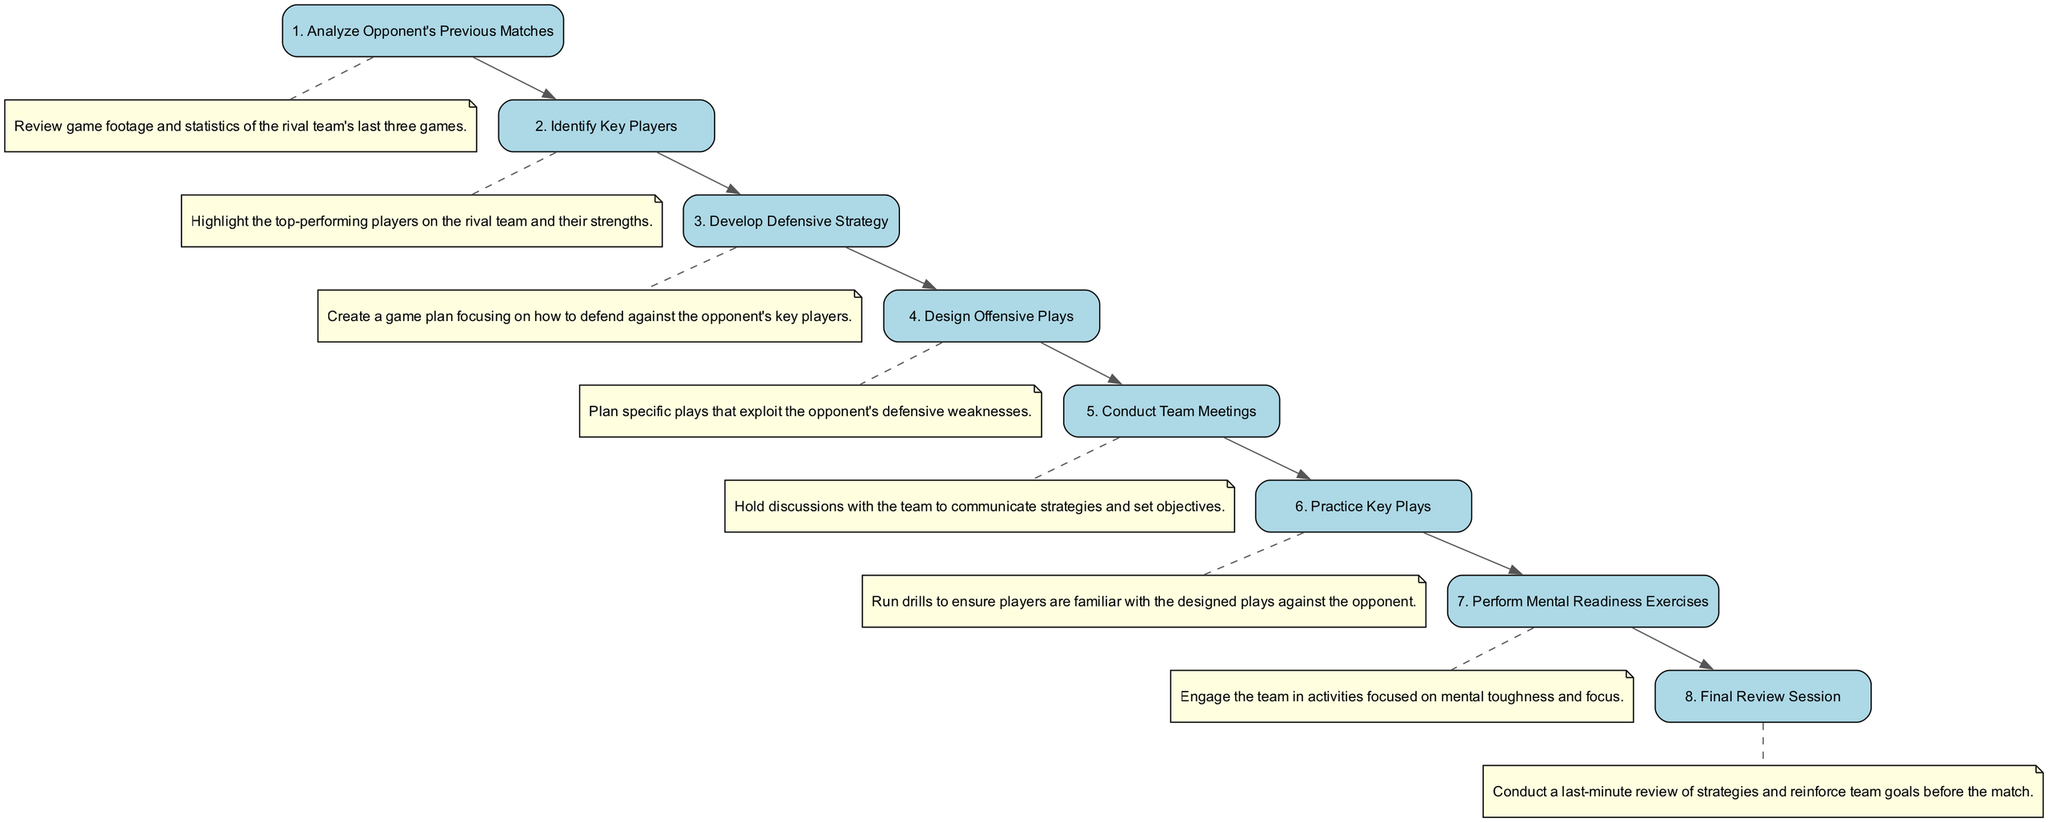What is the first step in the game preparation process? The first step is to "Analyze Opponent's Previous Matches," as it is the initial node in the sequence diagram.
Answer: Analyze Opponent's Previous Matches How many total steps are in the preparation process? There are 8 steps outlined in the sequence diagram, as indicated by the 8 nodes representing different actions.
Answer: 8 What step comes after "Identify Key Players"? The step that follows "Identify Key Players" is "Develop Defensive Strategy," which is the next node in the sequence.
Answer: Develop Defensive Strategy Which activities are mental readiness exercises? "Perform Mental Readiness Exercises" is the specific activity mentioned that focuses on mental toughness and is connected in the sequence to the preparation process.
Answer: Perform Mental Readiness Exercises What is the last step before the final review session? "Practice Key Plays" is the step immediately preceding the "Final Review Session," as it directly connects to it in the diagram.
Answer: Practice Key Plays Which two steps focus most on planning strategies? The steps "Develop Defensive Strategy" and "Design Offensive Plays" both involve planning strategies against the opponent's strengths and weaknesses.
Answer: Develop Defensive Strategy, Design Offensive Plays Which step has a note connected to it describing a game footage review? The step "Analyze Opponent's Previous Matches" has a note connected to it that describes the review of game footage and statistics.
Answer: Analyze Opponent's Previous Matches What are the last two steps in the sequence diagram? The last two steps in the sequence are "Perform Mental Readiness Exercises" and "Final Review Session," as they are the final actions taken in the preparation process.
Answer: Perform Mental Readiness Exercises, Final Review Session 